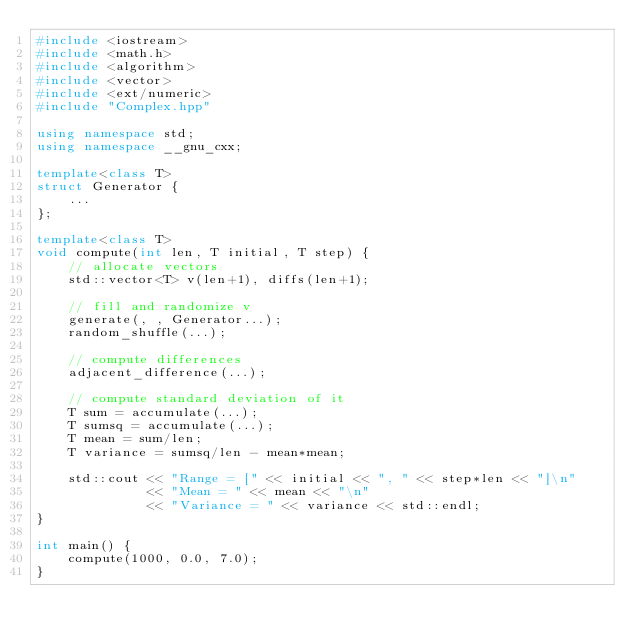Convert code to text. <code><loc_0><loc_0><loc_500><loc_500><_C++_>#include <iostream>
#include <math.h>
#include <algorithm>
#include <vector>
#include <ext/numeric>
#include "Complex.hpp"

using namespace std;
using namespace __gnu_cxx;

template<class T>
struct Generator {
    ...
};

template<class T>
void compute(int len, T initial, T step) {
    // allocate vectors
    std::vector<T> v(len+1), diffs(len+1);

    // fill and randomize v
    generate(, , Generator...);
    random_shuffle(...);
    
    // compute differences
    adjacent_difference(...);

    // compute standard deviation of it
    T sum = accumulate(...);
    T sumsq = accumulate(...);
    T mean = sum/len;
    T variance = sumsq/len - mean*mean;

    std::cout << "Range = [" << initial << ", " << step*len << "]\n"
              << "Mean = " << mean << "\n"
              << "Variance = " << variance << std::endl;
}

int main() {
    compute(1000, 0.0, 7.0);
}
</code> 